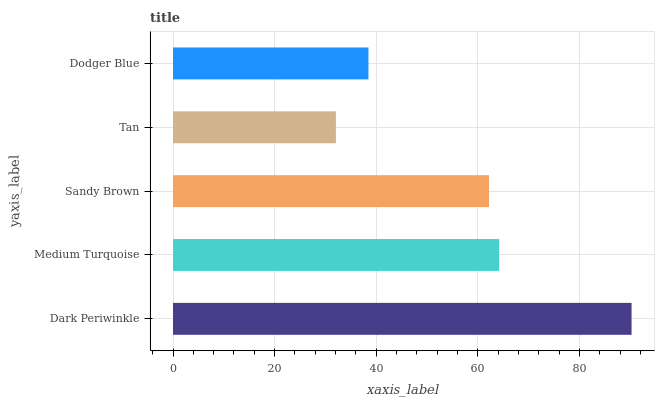Is Tan the minimum?
Answer yes or no. Yes. Is Dark Periwinkle the maximum?
Answer yes or no. Yes. Is Medium Turquoise the minimum?
Answer yes or no. No. Is Medium Turquoise the maximum?
Answer yes or no. No. Is Dark Periwinkle greater than Medium Turquoise?
Answer yes or no. Yes. Is Medium Turquoise less than Dark Periwinkle?
Answer yes or no. Yes. Is Medium Turquoise greater than Dark Periwinkle?
Answer yes or no. No. Is Dark Periwinkle less than Medium Turquoise?
Answer yes or no. No. Is Sandy Brown the high median?
Answer yes or no. Yes. Is Sandy Brown the low median?
Answer yes or no. Yes. Is Tan the high median?
Answer yes or no. No. Is Dark Periwinkle the low median?
Answer yes or no. No. 